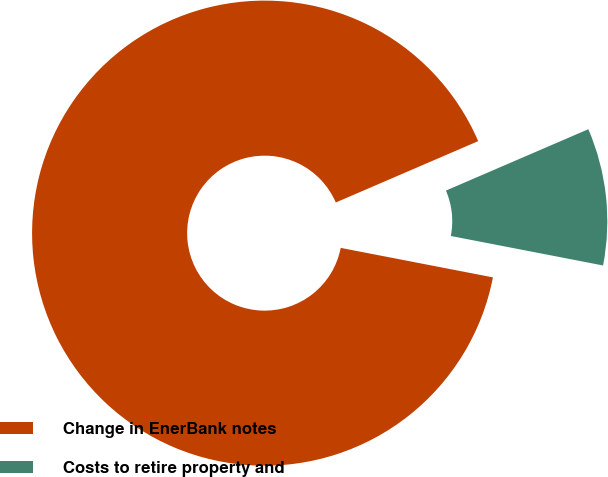<chart> <loc_0><loc_0><loc_500><loc_500><pie_chart><fcel>Change in EnerBank notes<fcel>Costs to retire property and<nl><fcel>90.48%<fcel>9.52%<nl></chart> 